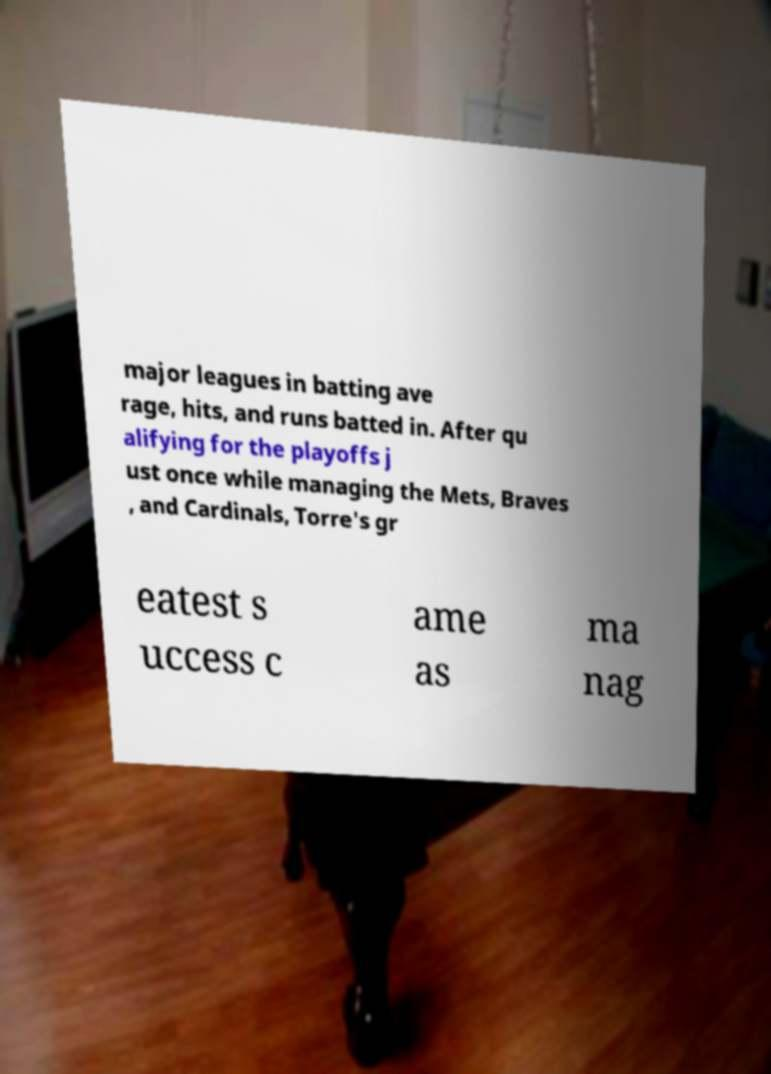There's text embedded in this image that I need extracted. Can you transcribe it verbatim? major leagues in batting ave rage, hits, and runs batted in. After qu alifying for the playoffs j ust once while managing the Mets, Braves , and Cardinals, Torre's gr eatest s uccess c ame as ma nag 